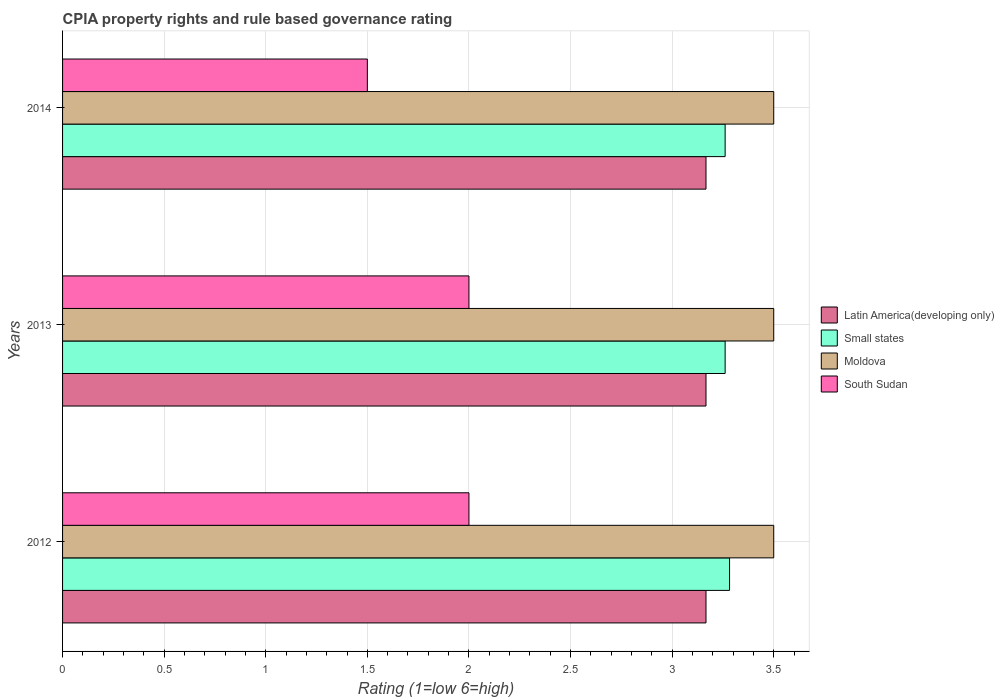How many different coloured bars are there?
Give a very brief answer. 4. How many groups of bars are there?
Your response must be concise. 3. Are the number of bars per tick equal to the number of legend labels?
Ensure brevity in your answer.  Yes. How many bars are there on the 3rd tick from the top?
Your answer should be compact. 4. How many bars are there on the 3rd tick from the bottom?
Your answer should be compact. 4. In how many cases, is the number of bars for a given year not equal to the number of legend labels?
Offer a terse response. 0. What is the CPIA rating in Latin America(developing only) in 2014?
Keep it short and to the point. 3.17. What is the total CPIA rating in Small states in the graph?
Make the answer very short. 9.8. What is the difference between the CPIA rating in South Sudan in 2013 and that in 2014?
Offer a very short reply. 0.5. What is the difference between the CPIA rating in Moldova in 2013 and the CPIA rating in Small states in 2012?
Keep it short and to the point. 0.22. In the year 2013, what is the difference between the CPIA rating in Moldova and CPIA rating in Latin America(developing only)?
Offer a terse response. 0.33. In how many years, is the CPIA rating in Latin America(developing only) greater than 2.3 ?
Your response must be concise. 3. What is the ratio of the CPIA rating in Small states in 2012 to that in 2013?
Ensure brevity in your answer.  1.01. What is the difference between the highest and the lowest CPIA rating in Small states?
Your answer should be very brief. 0.02. Is it the case that in every year, the sum of the CPIA rating in Small states and CPIA rating in Moldova is greater than the sum of CPIA rating in Latin America(developing only) and CPIA rating in South Sudan?
Ensure brevity in your answer.  Yes. What does the 2nd bar from the top in 2014 represents?
Your answer should be very brief. Moldova. What does the 4th bar from the bottom in 2013 represents?
Your answer should be very brief. South Sudan. Is it the case that in every year, the sum of the CPIA rating in Moldova and CPIA rating in Small states is greater than the CPIA rating in South Sudan?
Offer a terse response. Yes. Are all the bars in the graph horizontal?
Offer a terse response. Yes. How many years are there in the graph?
Your answer should be very brief. 3. Does the graph contain any zero values?
Your answer should be compact. No. Does the graph contain grids?
Offer a terse response. Yes. Where does the legend appear in the graph?
Keep it short and to the point. Center right. How many legend labels are there?
Keep it short and to the point. 4. How are the legend labels stacked?
Offer a very short reply. Vertical. What is the title of the graph?
Your response must be concise. CPIA property rights and rule based governance rating. What is the Rating (1=low 6=high) of Latin America(developing only) in 2012?
Provide a succinct answer. 3.17. What is the Rating (1=low 6=high) in Small states in 2012?
Your response must be concise. 3.28. What is the Rating (1=low 6=high) in Latin America(developing only) in 2013?
Make the answer very short. 3.17. What is the Rating (1=low 6=high) of Small states in 2013?
Make the answer very short. 3.26. What is the Rating (1=low 6=high) in Moldova in 2013?
Your answer should be very brief. 3.5. What is the Rating (1=low 6=high) of South Sudan in 2013?
Your answer should be compact. 2. What is the Rating (1=low 6=high) in Latin America(developing only) in 2014?
Provide a succinct answer. 3.17. What is the Rating (1=low 6=high) of Small states in 2014?
Your answer should be compact. 3.26. What is the Rating (1=low 6=high) of Moldova in 2014?
Make the answer very short. 3.5. Across all years, what is the maximum Rating (1=low 6=high) of Latin America(developing only)?
Give a very brief answer. 3.17. Across all years, what is the maximum Rating (1=low 6=high) of Small states?
Offer a very short reply. 3.28. Across all years, what is the maximum Rating (1=low 6=high) of Moldova?
Provide a short and direct response. 3.5. Across all years, what is the maximum Rating (1=low 6=high) of South Sudan?
Provide a short and direct response. 2. Across all years, what is the minimum Rating (1=low 6=high) in Latin America(developing only)?
Your response must be concise. 3.17. Across all years, what is the minimum Rating (1=low 6=high) of Small states?
Provide a succinct answer. 3.26. Across all years, what is the minimum Rating (1=low 6=high) in Moldova?
Offer a very short reply. 3.5. Across all years, what is the minimum Rating (1=low 6=high) in South Sudan?
Your answer should be very brief. 1.5. What is the total Rating (1=low 6=high) of Latin America(developing only) in the graph?
Your answer should be compact. 9.5. What is the total Rating (1=low 6=high) in Small states in the graph?
Your answer should be very brief. 9.8. What is the difference between the Rating (1=low 6=high) in Latin America(developing only) in 2012 and that in 2013?
Give a very brief answer. 0. What is the difference between the Rating (1=low 6=high) of Small states in 2012 and that in 2013?
Provide a short and direct response. 0.02. What is the difference between the Rating (1=low 6=high) in Latin America(developing only) in 2012 and that in 2014?
Offer a very short reply. 0. What is the difference between the Rating (1=low 6=high) of Small states in 2012 and that in 2014?
Provide a short and direct response. 0.02. What is the difference between the Rating (1=low 6=high) in South Sudan in 2012 and that in 2014?
Ensure brevity in your answer.  0.5. What is the difference between the Rating (1=low 6=high) in Latin America(developing only) in 2013 and that in 2014?
Offer a terse response. 0. What is the difference between the Rating (1=low 6=high) in Latin America(developing only) in 2012 and the Rating (1=low 6=high) in Small states in 2013?
Your response must be concise. -0.09. What is the difference between the Rating (1=low 6=high) in Latin America(developing only) in 2012 and the Rating (1=low 6=high) in Moldova in 2013?
Make the answer very short. -0.33. What is the difference between the Rating (1=low 6=high) in Latin America(developing only) in 2012 and the Rating (1=low 6=high) in South Sudan in 2013?
Ensure brevity in your answer.  1.17. What is the difference between the Rating (1=low 6=high) of Small states in 2012 and the Rating (1=low 6=high) of Moldova in 2013?
Provide a short and direct response. -0.22. What is the difference between the Rating (1=low 6=high) of Small states in 2012 and the Rating (1=low 6=high) of South Sudan in 2013?
Give a very brief answer. 1.28. What is the difference between the Rating (1=low 6=high) in Moldova in 2012 and the Rating (1=low 6=high) in South Sudan in 2013?
Your answer should be compact. 1.5. What is the difference between the Rating (1=low 6=high) in Latin America(developing only) in 2012 and the Rating (1=low 6=high) in Small states in 2014?
Your response must be concise. -0.09. What is the difference between the Rating (1=low 6=high) of Latin America(developing only) in 2012 and the Rating (1=low 6=high) of South Sudan in 2014?
Offer a terse response. 1.67. What is the difference between the Rating (1=low 6=high) of Small states in 2012 and the Rating (1=low 6=high) of Moldova in 2014?
Offer a terse response. -0.22. What is the difference between the Rating (1=low 6=high) in Small states in 2012 and the Rating (1=low 6=high) in South Sudan in 2014?
Offer a very short reply. 1.78. What is the difference between the Rating (1=low 6=high) of Moldova in 2012 and the Rating (1=low 6=high) of South Sudan in 2014?
Keep it short and to the point. 2. What is the difference between the Rating (1=low 6=high) of Latin America(developing only) in 2013 and the Rating (1=low 6=high) of Small states in 2014?
Offer a very short reply. -0.09. What is the difference between the Rating (1=low 6=high) of Latin America(developing only) in 2013 and the Rating (1=low 6=high) of Moldova in 2014?
Provide a succinct answer. -0.33. What is the difference between the Rating (1=low 6=high) in Latin America(developing only) in 2013 and the Rating (1=low 6=high) in South Sudan in 2014?
Offer a very short reply. 1.67. What is the difference between the Rating (1=low 6=high) of Small states in 2013 and the Rating (1=low 6=high) of Moldova in 2014?
Provide a succinct answer. -0.24. What is the difference between the Rating (1=low 6=high) in Small states in 2013 and the Rating (1=low 6=high) in South Sudan in 2014?
Provide a succinct answer. 1.76. What is the difference between the Rating (1=low 6=high) of Moldova in 2013 and the Rating (1=low 6=high) of South Sudan in 2014?
Your response must be concise. 2. What is the average Rating (1=low 6=high) of Latin America(developing only) per year?
Offer a terse response. 3.17. What is the average Rating (1=low 6=high) in Small states per year?
Your answer should be compact. 3.27. What is the average Rating (1=low 6=high) of South Sudan per year?
Your answer should be very brief. 1.83. In the year 2012, what is the difference between the Rating (1=low 6=high) of Latin America(developing only) and Rating (1=low 6=high) of Small states?
Make the answer very short. -0.12. In the year 2012, what is the difference between the Rating (1=low 6=high) in Small states and Rating (1=low 6=high) in Moldova?
Provide a succinct answer. -0.22. In the year 2012, what is the difference between the Rating (1=low 6=high) in Small states and Rating (1=low 6=high) in South Sudan?
Offer a very short reply. 1.28. In the year 2013, what is the difference between the Rating (1=low 6=high) in Latin America(developing only) and Rating (1=low 6=high) in Small states?
Your response must be concise. -0.09. In the year 2013, what is the difference between the Rating (1=low 6=high) in Latin America(developing only) and Rating (1=low 6=high) in Moldova?
Provide a short and direct response. -0.33. In the year 2013, what is the difference between the Rating (1=low 6=high) in Small states and Rating (1=low 6=high) in Moldova?
Ensure brevity in your answer.  -0.24. In the year 2013, what is the difference between the Rating (1=low 6=high) of Small states and Rating (1=low 6=high) of South Sudan?
Keep it short and to the point. 1.26. In the year 2013, what is the difference between the Rating (1=low 6=high) in Moldova and Rating (1=low 6=high) in South Sudan?
Offer a terse response. 1.5. In the year 2014, what is the difference between the Rating (1=low 6=high) in Latin America(developing only) and Rating (1=low 6=high) in Small states?
Make the answer very short. -0.09. In the year 2014, what is the difference between the Rating (1=low 6=high) in Latin America(developing only) and Rating (1=low 6=high) in Moldova?
Your response must be concise. -0.33. In the year 2014, what is the difference between the Rating (1=low 6=high) of Small states and Rating (1=low 6=high) of Moldova?
Provide a short and direct response. -0.24. In the year 2014, what is the difference between the Rating (1=low 6=high) in Small states and Rating (1=low 6=high) in South Sudan?
Give a very brief answer. 1.76. In the year 2014, what is the difference between the Rating (1=low 6=high) in Moldova and Rating (1=low 6=high) in South Sudan?
Keep it short and to the point. 2. What is the ratio of the Rating (1=low 6=high) in Latin America(developing only) in 2012 to that in 2014?
Your answer should be compact. 1. What is the ratio of the Rating (1=low 6=high) of Small states in 2012 to that in 2014?
Provide a short and direct response. 1.01. What is the ratio of the Rating (1=low 6=high) of Moldova in 2012 to that in 2014?
Your answer should be very brief. 1. What is the ratio of the Rating (1=low 6=high) in South Sudan in 2012 to that in 2014?
Your answer should be compact. 1.33. What is the ratio of the Rating (1=low 6=high) of Latin America(developing only) in 2013 to that in 2014?
Your response must be concise. 1. What is the ratio of the Rating (1=low 6=high) of Small states in 2013 to that in 2014?
Offer a terse response. 1. What is the ratio of the Rating (1=low 6=high) in Moldova in 2013 to that in 2014?
Offer a terse response. 1. What is the ratio of the Rating (1=low 6=high) in South Sudan in 2013 to that in 2014?
Your response must be concise. 1.33. What is the difference between the highest and the second highest Rating (1=low 6=high) of Latin America(developing only)?
Make the answer very short. 0. What is the difference between the highest and the second highest Rating (1=low 6=high) of Small states?
Your answer should be very brief. 0.02. What is the difference between the highest and the second highest Rating (1=low 6=high) in Moldova?
Your answer should be compact. 0. What is the difference between the highest and the second highest Rating (1=low 6=high) of South Sudan?
Provide a succinct answer. 0. What is the difference between the highest and the lowest Rating (1=low 6=high) of Small states?
Keep it short and to the point. 0.02. What is the difference between the highest and the lowest Rating (1=low 6=high) of Moldova?
Provide a succinct answer. 0. 